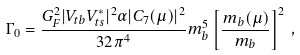Convert formula to latex. <formula><loc_0><loc_0><loc_500><loc_500>\Gamma _ { 0 } = { \frac { G _ { F } ^ { 2 } | V _ { t b } V _ { t s } ^ { * } | ^ { 2 } \alpha | C _ { 7 } ( \mu ) | ^ { 2 } } { 3 2 \pi ^ { 4 } } } m _ { b } ^ { 5 } \left [ \frac { m _ { b } ( \mu ) } { m _ { b } } \right ] ^ { 2 } \, ,</formula> 